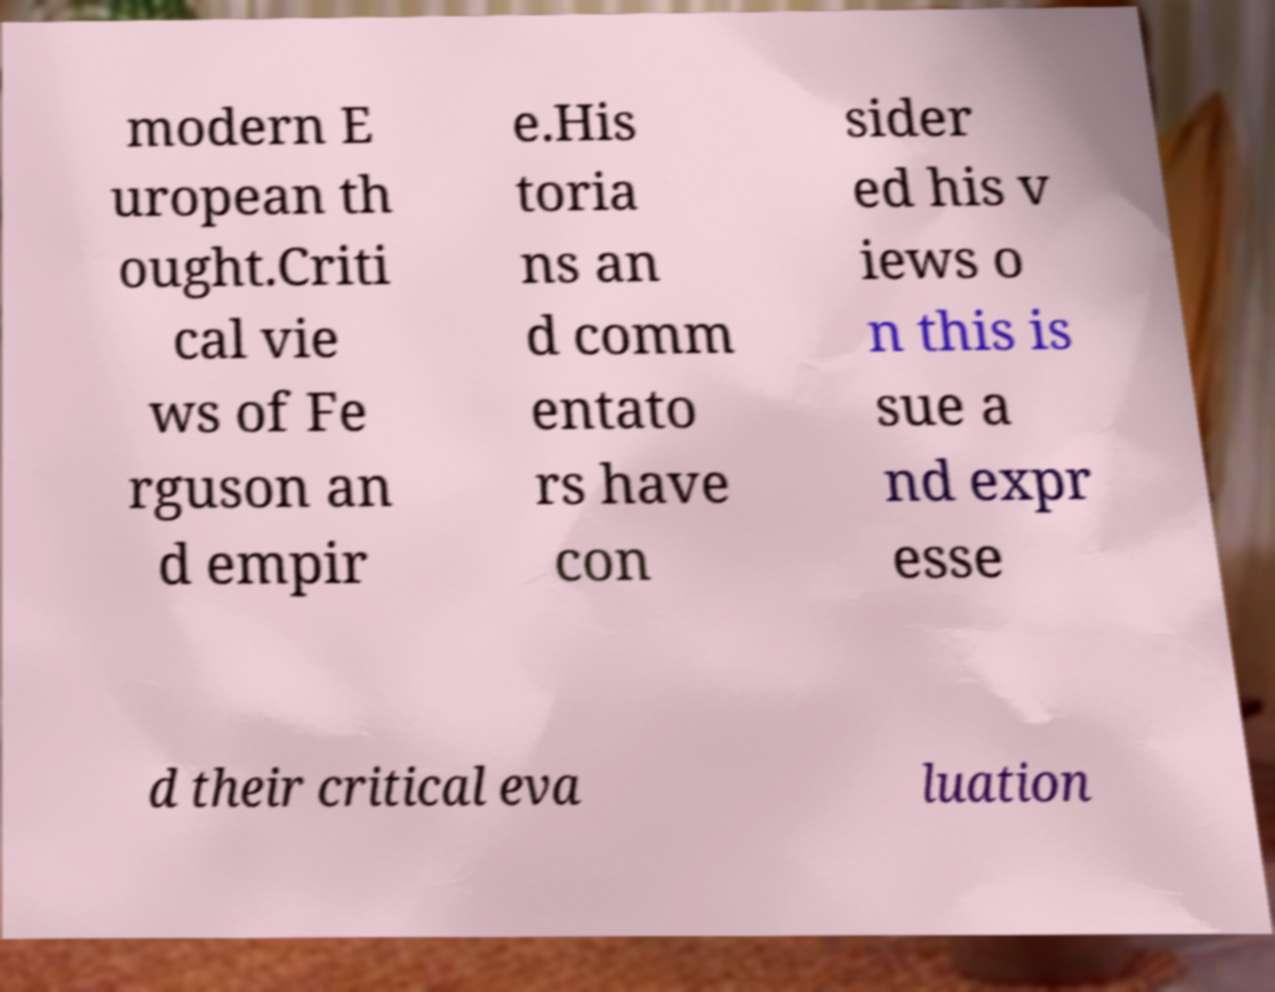Could you assist in decoding the text presented in this image and type it out clearly? modern E uropean th ought.Criti cal vie ws of Fe rguson an d empir e.His toria ns an d comm entato rs have con sider ed his v iews o n this is sue a nd expr esse d their critical eva luation 